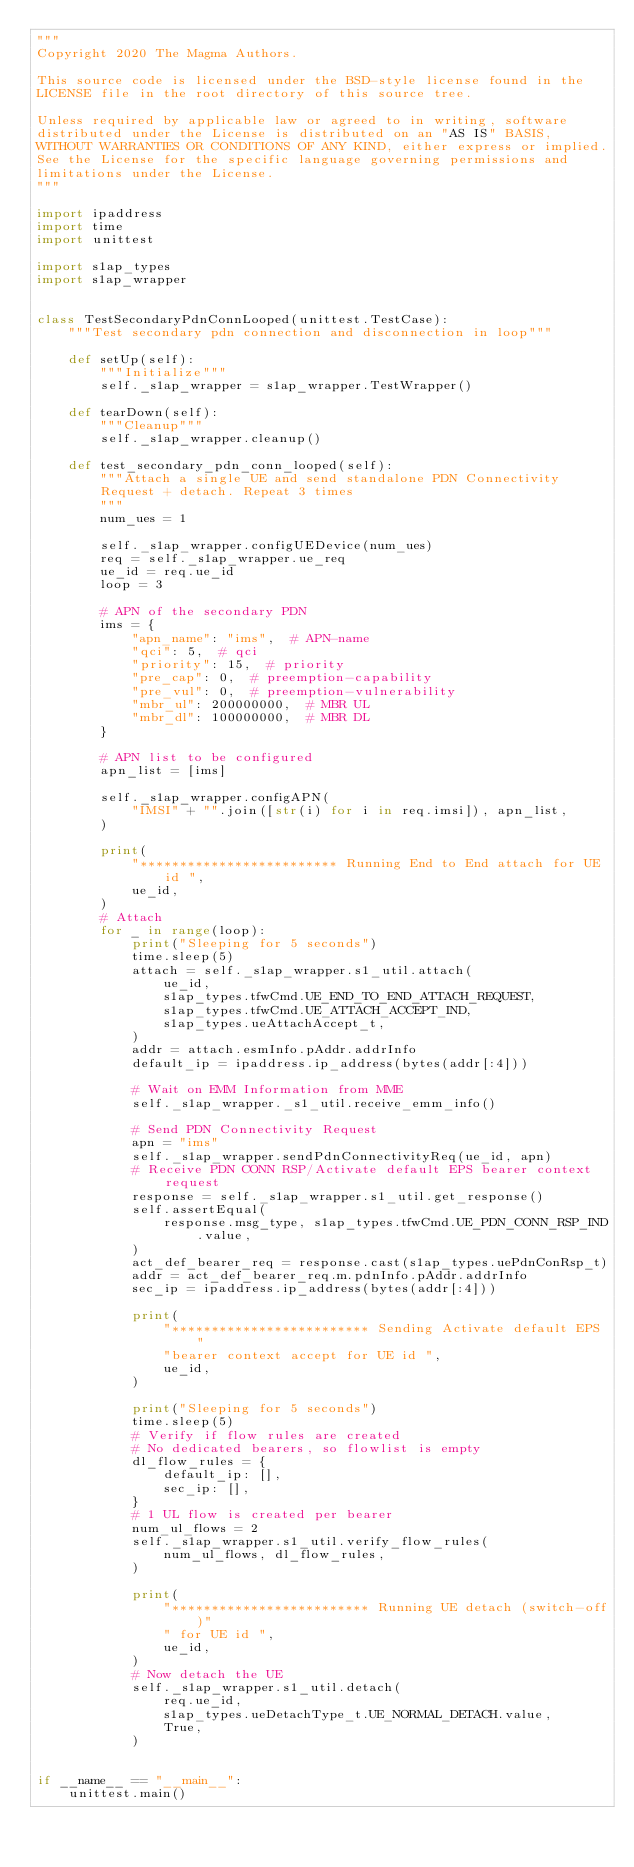<code> <loc_0><loc_0><loc_500><loc_500><_Python_>"""
Copyright 2020 The Magma Authors.

This source code is licensed under the BSD-style license found in the
LICENSE file in the root directory of this source tree.

Unless required by applicable law or agreed to in writing, software
distributed under the License is distributed on an "AS IS" BASIS,
WITHOUT WARRANTIES OR CONDITIONS OF ANY KIND, either express or implied.
See the License for the specific language governing permissions and
limitations under the License.
"""

import ipaddress
import time
import unittest

import s1ap_types
import s1ap_wrapper


class TestSecondaryPdnConnLooped(unittest.TestCase):
    """Test secondary pdn connection and disconnection in loop"""

    def setUp(self):
        """Initialize"""
        self._s1ap_wrapper = s1ap_wrapper.TestWrapper()

    def tearDown(self):
        """Cleanup"""
        self._s1ap_wrapper.cleanup()

    def test_secondary_pdn_conn_looped(self):
        """Attach a single UE and send standalone PDN Connectivity
        Request + detach. Repeat 3 times
        """
        num_ues = 1

        self._s1ap_wrapper.configUEDevice(num_ues)
        req = self._s1ap_wrapper.ue_req
        ue_id = req.ue_id
        loop = 3

        # APN of the secondary PDN
        ims = {
            "apn_name": "ims",  # APN-name
            "qci": 5,  # qci
            "priority": 15,  # priority
            "pre_cap": 0,  # preemption-capability
            "pre_vul": 0,  # preemption-vulnerability
            "mbr_ul": 200000000,  # MBR UL
            "mbr_dl": 100000000,  # MBR DL
        }

        # APN list to be configured
        apn_list = [ims]

        self._s1ap_wrapper.configAPN(
            "IMSI" + "".join([str(i) for i in req.imsi]), apn_list,
        )

        print(
            "************************* Running End to End attach for UE id ",
            ue_id,
        )
        # Attach
        for _ in range(loop):
            print("Sleeping for 5 seconds")
            time.sleep(5)
            attach = self._s1ap_wrapper.s1_util.attach(
                ue_id,
                s1ap_types.tfwCmd.UE_END_TO_END_ATTACH_REQUEST,
                s1ap_types.tfwCmd.UE_ATTACH_ACCEPT_IND,
                s1ap_types.ueAttachAccept_t,
            )
            addr = attach.esmInfo.pAddr.addrInfo
            default_ip = ipaddress.ip_address(bytes(addr[:4]))

            # Wait on EMM Information from MME
            self._s1ap_wrapper._s1_util.receive_emm_info()

            # Send PDN Connectivity Request
            apn = "ims"
            self._s1ap_wrapper.sendPdnConnectivityReq(ue_id, apn)
            # Receive PDN CONN RSP/Activate default EPS bearer context request
            response = self._s1ap_wrapper.s1_util.get_response()
            self.assertEqual(
                response.msg_type, s1ap_types.tfwCmd.UE_PDN_CONN_RSP_IND.value,
            )
            act_def_bearer_req = response.cast(s1ap_types.uePdnConRsp_t)
            addr = act_def_bearer_req.m.pdnInfo.pAddr.addrInfo
            sec_ip = ipaddress.ip_address(bytes(addr[:4]))

            print(
                "************************* Sending Activate default EPS "
                "bearer context accept for UE id ",
                ue_id,
            )

            print("Sleeping for 5 seconds")
            time.sleep(5)
            # Verify if flow rules are created
            # No dedicated bearers, so flowlist is empty
            dl_flow_rules = {
                default_ip: [],
                sec_ip: [],
            }
            # 1 UL flow is created per bearer
            num_ul_flows = 2
            self._s1ap_wrapper.s1_util.verify_flow_rules(
                num_ul_flows, dl_flow_rules,
            )

            print(
                "************************* Running UE detach (switch-off)"
                " for UE id ",
                ue_id,
            )
            # Now detach the UE
            self._s1ap_wrapper.s1_util.detach(
                req.ue_id,
                s1ap_types.ueDetachType_t.UE_NORMAL_DETACH.value,
                True,
            )


if __name__ == "__main__":
    unittest.main()
</code> 